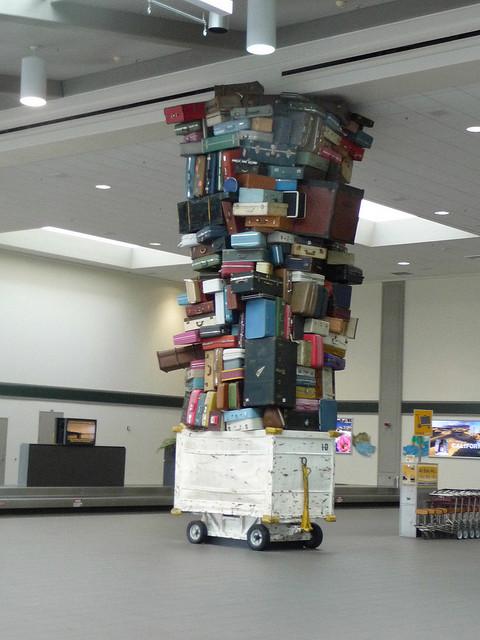Can anymore luggage fit?
Be succinct. No. What color strap is around the big piece of luggage?
Write a very short answer. Yellow. What color is the floor?
Answer briefly. Gray. Where is the luggage?
Answer briefly. Cart. What is stacked up?
Give a very brief answer. Luggage. How many wheels are on the luggage?
Give a very brief answer. 4. What facility is here?
Write a very short answer. Airport. 